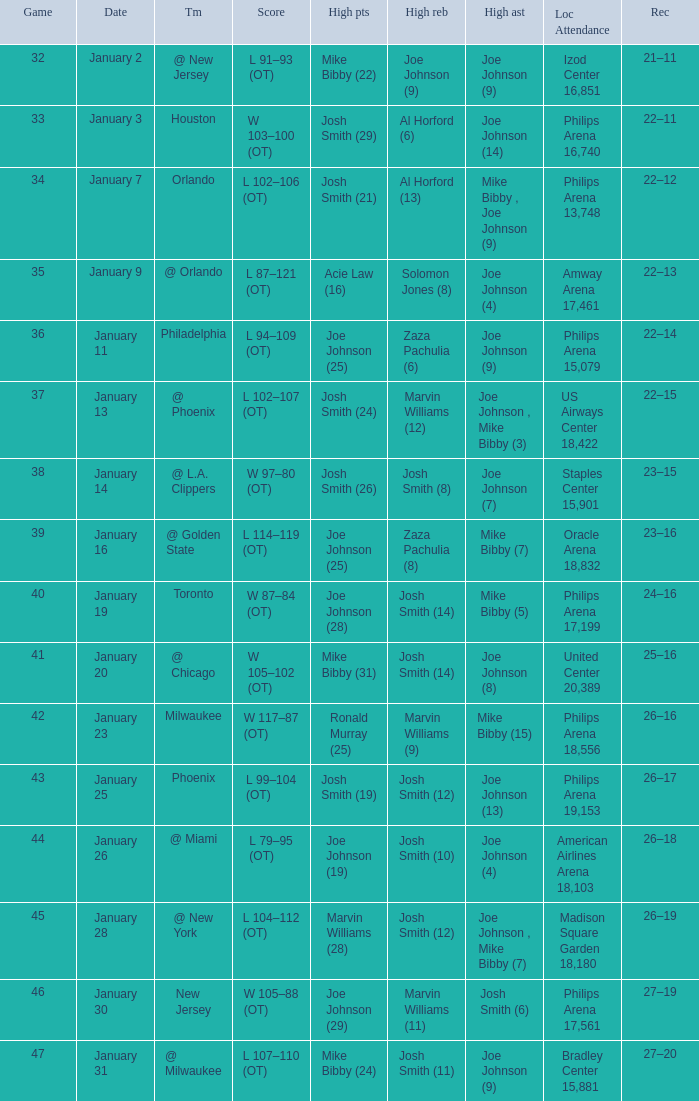Which date was game 35 on? January 9. 